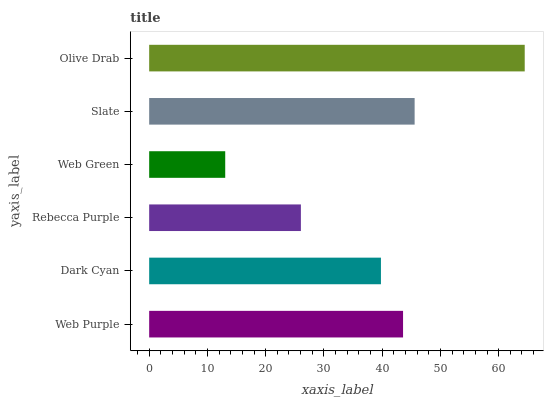Is Web Green the minimum?
Answer yes or no. Yes. Is Olive Drab the maximum?
Answer yes or no. Yes. Is Dark Cyan the minimum?
Answer yes or no. No. Is Dark Cyan the maximum?
Answer yes or no. No. Is Web Purple greater than Dark Cyan?
Answer yes or no. Yes. Is Dark Cyan less than Web Purple?
Answer yes or no. Yes. Is Dark Cyan greater than Web Purple?
Answer yes or no. No. Is Web Purple less than Dark Cyan?
Answer yes or no. No. Is Web Purple the high median?
Answer yes or no. Yes. Is Dark Cyan the low median?
Answer yes or no. Yes. Is Web Green the high median?
Answer yes or no. No. Is Rebecca Purple the low median?
Answer yes or no. No. 